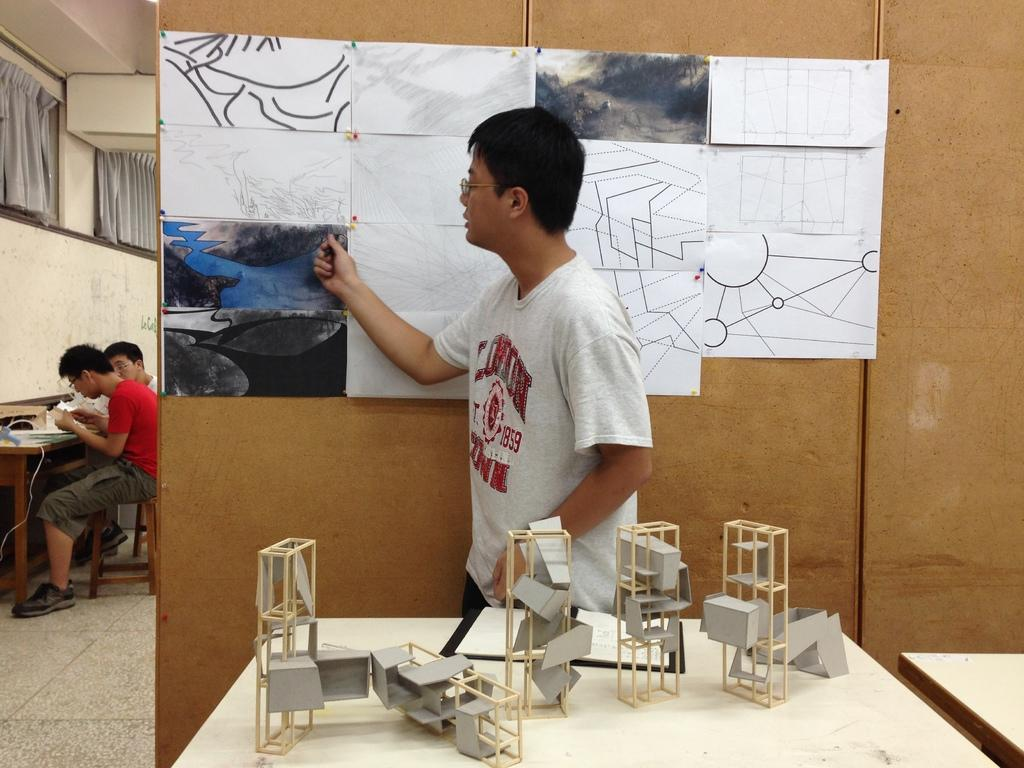What is the person in the image doing? There is a person standing at a table in the image. What can be seen on the wall in the image? There are paper posters on the wall in the image. What are the two men in the background doing? In the background, there are two men sitting on chairs at a table. How many frogs are sitting on the chairs with the two men in the image? There are no frogs present in the image; only the two men are sitting on chairs in the background. What type of comfort does the person standing at the table provide for the insects in the image? There are no insects present in the image, so no comfort is provided for them. 